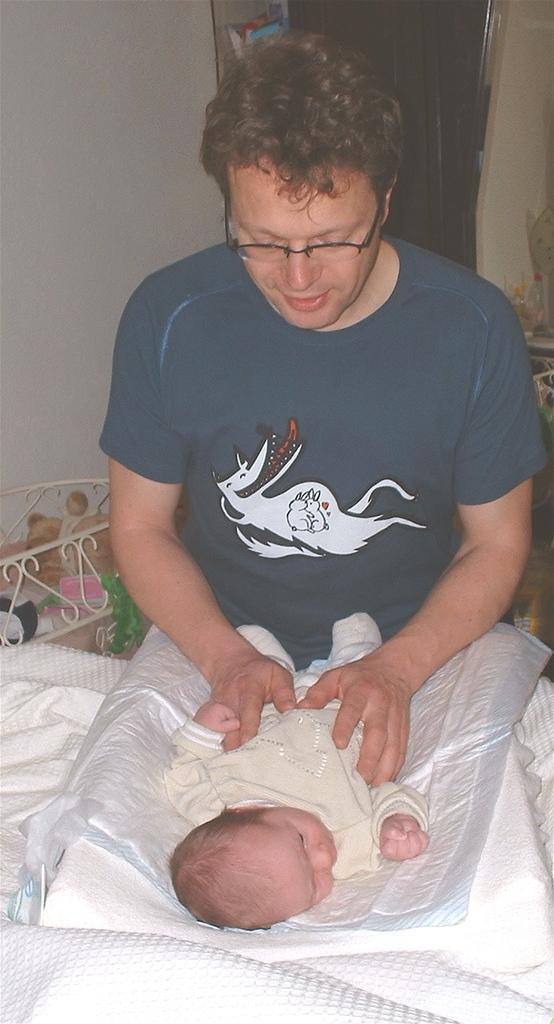In one or two sentences, can you explain what this image depicts? In-front of this person a baby is lying. This person is looking at this baby. Background there are things and curtain. 